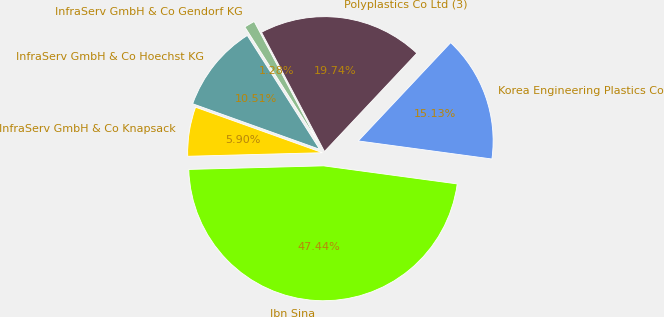<chart> <loc_0><loc_0><loc_500><loc_500><pie_chart><fcel>Ibn Sina<fcel>Korea Engineering Plastics Co<fcel>Polyplastics Co Ltd (3)<fcel>InfraServ GmbH & Co Gendorf KG<fcel>InfraServ GmbH & Co Hoechst KG<fcel>InfraServ GmbH & Co Knapsack<nl><fcel>47.44%<fcel>15.13%<fcel>19.74%<fcel>1.28%<fcel>10.51%<fcel>5.9%<nl></chart> 